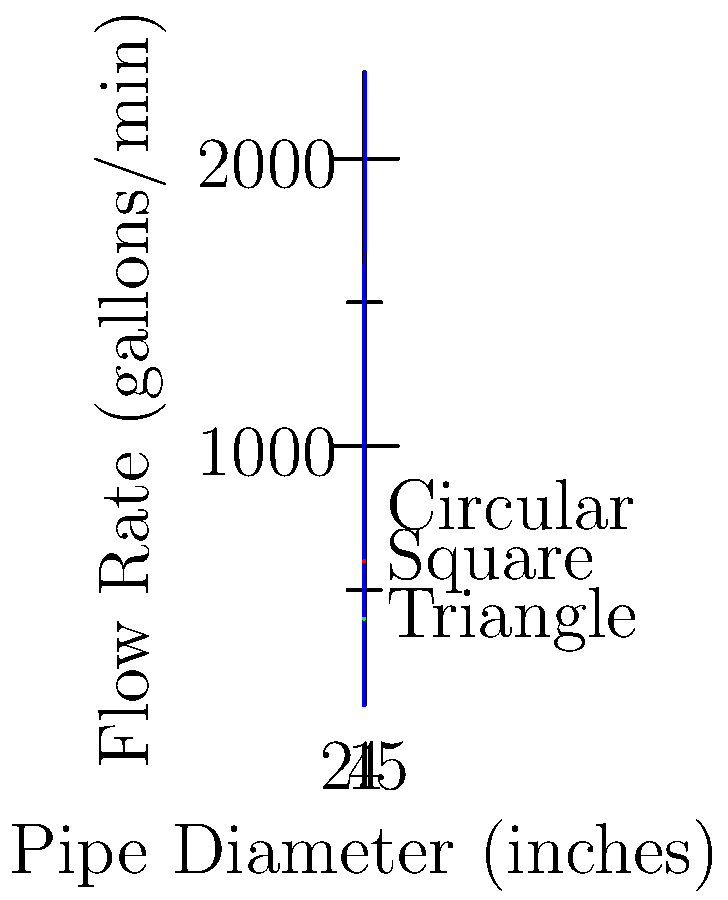In a twist of fate worthy of a plumbing sitcom, you're tasked with selecting the optimal pipe shape for a new water system. Given the flow rates shown in the graph for circular pipes, and knowing that square pipes flow at 80% and triangular pipes at 60% of circular pipes' rates, which shape would you choose to maximize flow while minimizing material costs? Express your answer as a pun-tastic pipe dream! Let's flow through this step-by-step:

1) First, we need to analyze the flow rates for circular pipes:
   - 1 inch diameter: 100 gallons/min
   - 2 inch diameter: 500 gallons/min
   - 3 inch diameter: 1200 gallons/min
   - 4 inch diameter: 2300 gallons/min

2) Now, let's calculate the flow rates for square and triangular pipes:
   - Square pipes: 80% of circular
   - Triangular pipes: 60% of circular

3) For a 4-inch pipe:
   - Circular: 2300 gallons/min
   - Square: $2300 \times 0.8 = 1840$ gallons/min
   - Triangular: $2300 \times 0.6 = 1380$ gallons/min

4) To minimize material costs, we need to consider the perimeter of each shape:
   - Circle: $\pi d = \pi \times 4 \approx 12.57$ inches
   - Square: $4s = 4 \times 4 = 16$ inches
   - Triangle (equilateral): $3s = 3 \times 4 \approx 12$ inches

5) Comparing flow rate to perimeter ratio:
   - Circular: $2300 / 12.57 \approx 183$ (gallons/min)/inch
   - Square: $1840 / 16 = 115$ (gallons/min)/inch
   - Triangular: $1380 / 12 \approx 115$ (gallons/min)/inch

6) The circular pipe provides the highest flow rate per unit of material used.
Answer: Circle gets the square! It's clearly a-round the best choice for this pipe dream. 